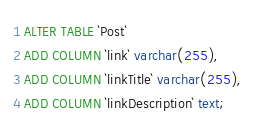Convert code to text. <code><loc_0><loc_0><loc_500><loc_500><_SQL_>ALTER TABLE `Post`
ADD COLUMN `link` varchar(255),
ADD COLUMN `linkTitle` varchar(255),
ADD COLUMN `linkDescription` text;
</code> 